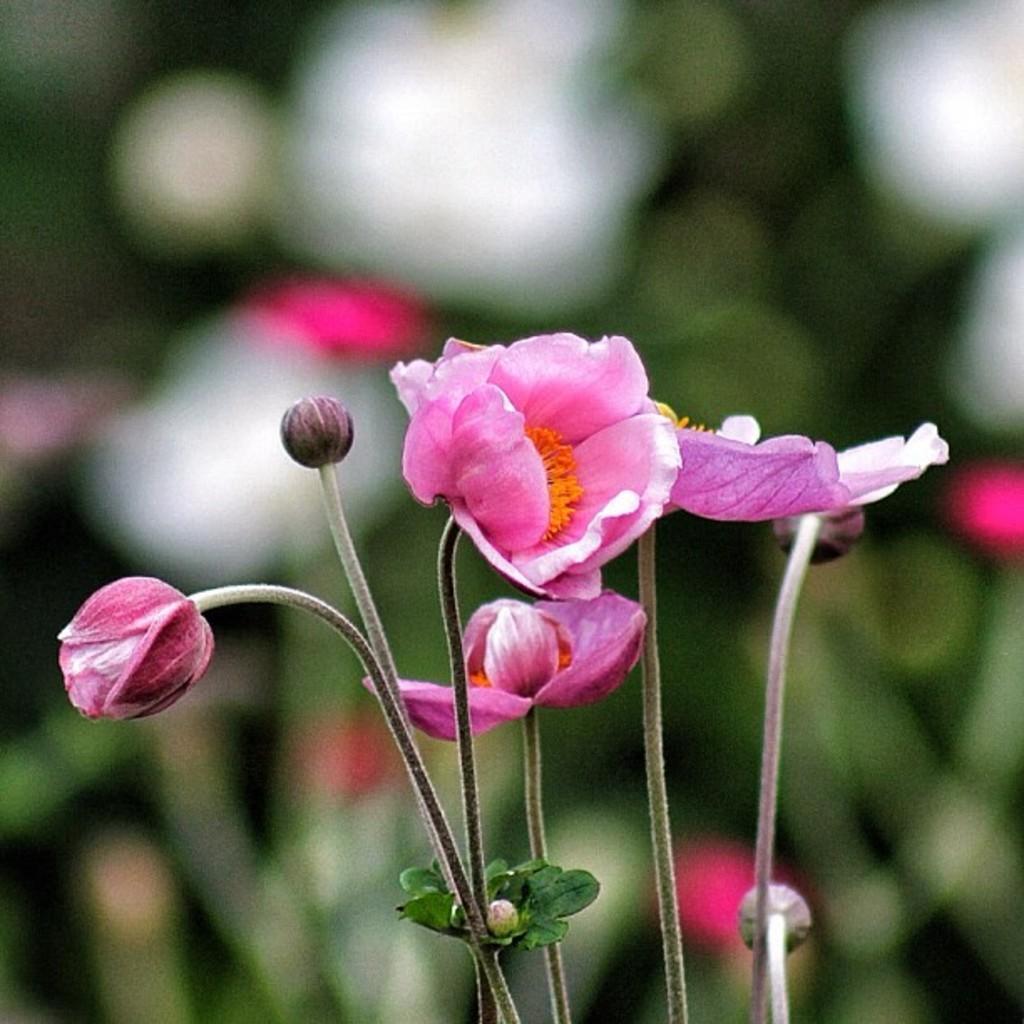Could you give a brief overview of what you see in this image? In this image there are flowers, in the background it is blurred. 